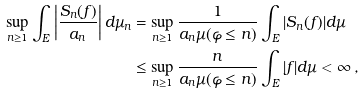<formula> <loc_0><loc_0><loc_500><loc_500>\sup _ { n \geq 1 } \int _ { E } \left | \frac { S _ { n } ( f ) } { a _ { n } } \right | d \mu _ { n } & = \sup _ { n \geq 1 } \frac { 1 } { a _ { n } \mu ( \varphi \leq n ) } \int _ { E } | S _ { n } ( f ) | d \mu \\ & \leq \sup _ { n \geq 1 } \frac { n } { a _ { n } \mu ( \varphi \leq n ) } \int _ { E } | f | d \mu < \infty \, ,</formula> 